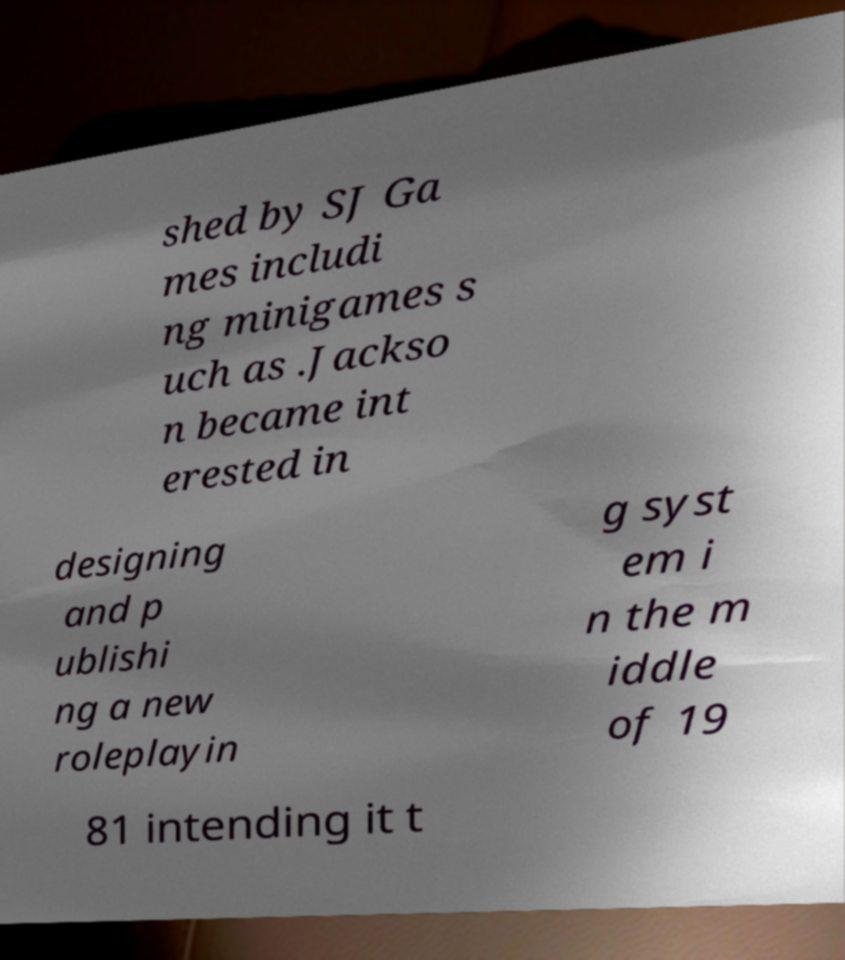For documentation purposes, I need the text within this image transcribed. Could you provide that? shed by SJ Ga mes includi ng minigames s uch as .Jackso n became int erested in designing and p ublishi ng a new roleplayin g syst em i n the m iddle of 19 81 intending it t 